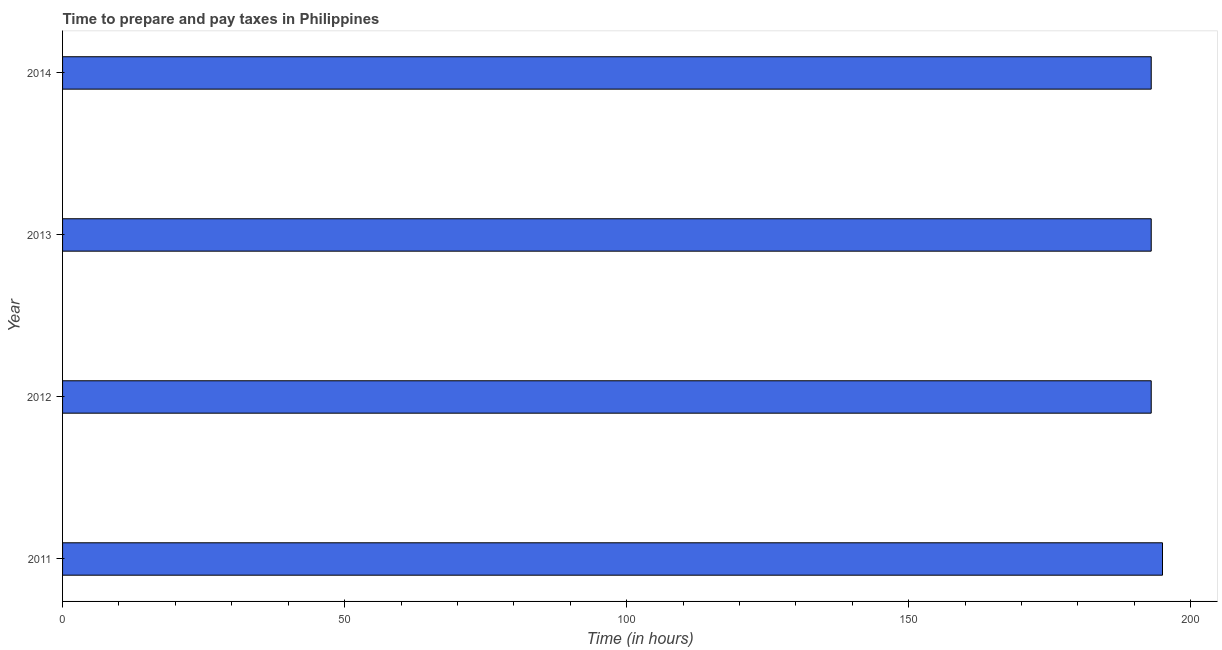Does the graph contain grids?
Offer a terse response. No. What is the title of the graph?
Provide a short and direct response. Time to prepare and pay taxes in Philippines. What is the label or title of the X-axis?
Keep it short and to the point. Time (in hours). What is the label or title of the Y-axis?
Offer a very short reply. Year. What is the time to prepare and pay taxes in 2013?
Offer a very short reply. 193. Across all years, what is the maximum time to prepare and pay taxes?
Keep it short and to the point. 195. Across all years, what is the minimum time to prepare and pay taxes?
Provide a succinct answer. 193. In which year was the time to prepare and pay taxes maximum?
Keep it short and to the point. 2011. What is the sum of the time to prepare and pay taxes?
Your answer should be very brief. 774. What is the average time to prepare and pay taxes per year?
Your answer should be very brief. 193. What is the median time to prepare and pay taxes?
Your answer should be compact. 193. Do a majority of the years between 2011 and 2013 (inclusive) have time to prepare and pay taxes greater than 140 hours?
Provide a short and direct response. Yes. Is the difference between the time to prepare and pay taxes in 2011 and 2014 greater than the difference between any two years?
Ensure brevity in your answer.  Yes. What is the difference between the highest and the second highest time to prepare and pay taxes?
Provide a short and direct response. 2. Is the sum of the time to prepare and pay taxes in 2011 and 2014 greater than the maximum time to prepare and pay taxes across all years?
Provide a short and direct response. Yes. What is the difference between the highest and the lowest time to prepare and pay taxes?
Ensure brevity in your answer.  2. In how many years, is the time to prepare and pay taxes greater than the average time to prepare and pay taxes taken over all years?
Keep it short and to the point. 1. How many bars are there?
Make the answer very short. 4. Are all the bars in the graph horizontal?
Give a very brief answer. Yes. Are the values on the major ticks of X-axis written in scientific E-notation?
Your answer should be compact. No. What is the Time (in hours) in 2011?
Offer a terse response. 195. What is the Time (in hours) in 2012?
Offer a terse response. 193. What is the Time (in hours) of 2013?
Your answer should be compact. 193. What is the Time (in hours) in 2014?
Your response must be concise. 193. What is the difference between the Time (in hours) in 2011 and 2014?
Keep it short and to the point. 2. What is the difference between the Time (in hours) in 2012 and 2014?
Offer a terse response. 0. What is the ratio of the Time (in hours) in 2011 to that in 2012?
Provide a short and direct response. 1.01. What is the ratio of the Time (in hours) in 2011 to that in 2014?
Your answer should be compact. 1.01. What is the ratio of the Time (in hours) in 2012 to that in 2014?
Your answer should be very brief. 1. What is the ratio of the Time (in hours) in 2013 to that in 2014?
Give a very brief answer. 1. 